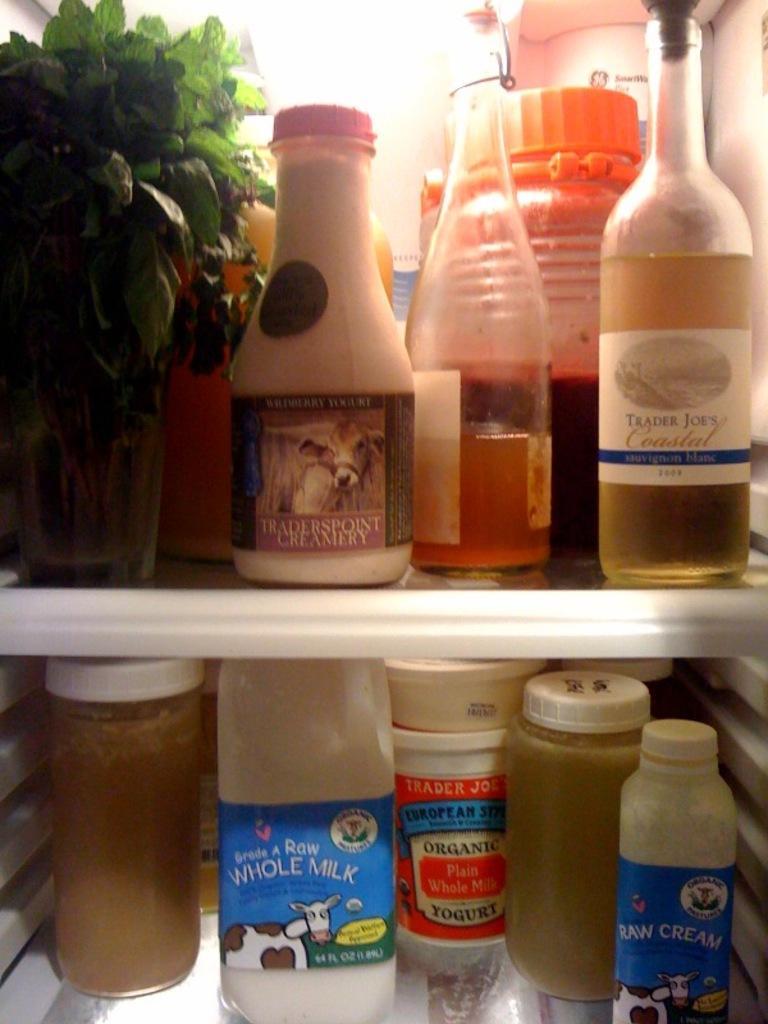How would you summarize this image in a sentence or two? In the image we can see there are bottles which are kept in a shelf. 